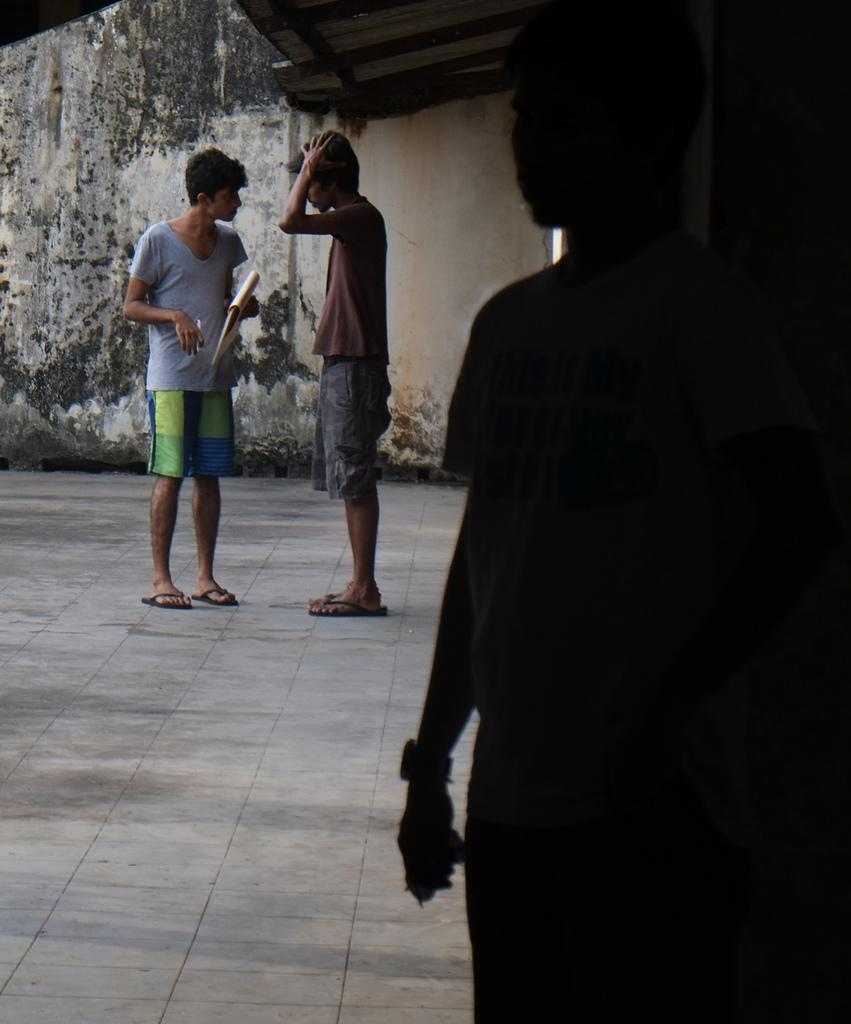How many people are present in the image? There are three persons standing in the image. What objects are being held by the people in the image? One person is holding a book, and another person is holding a pen. What can be seen in the background of the image? There is a wall in the background of the image. How many sisters does the person holding the pen have in the image? There is no information about sisters in the image, as it only mentions three persons and the objects they are holding. 